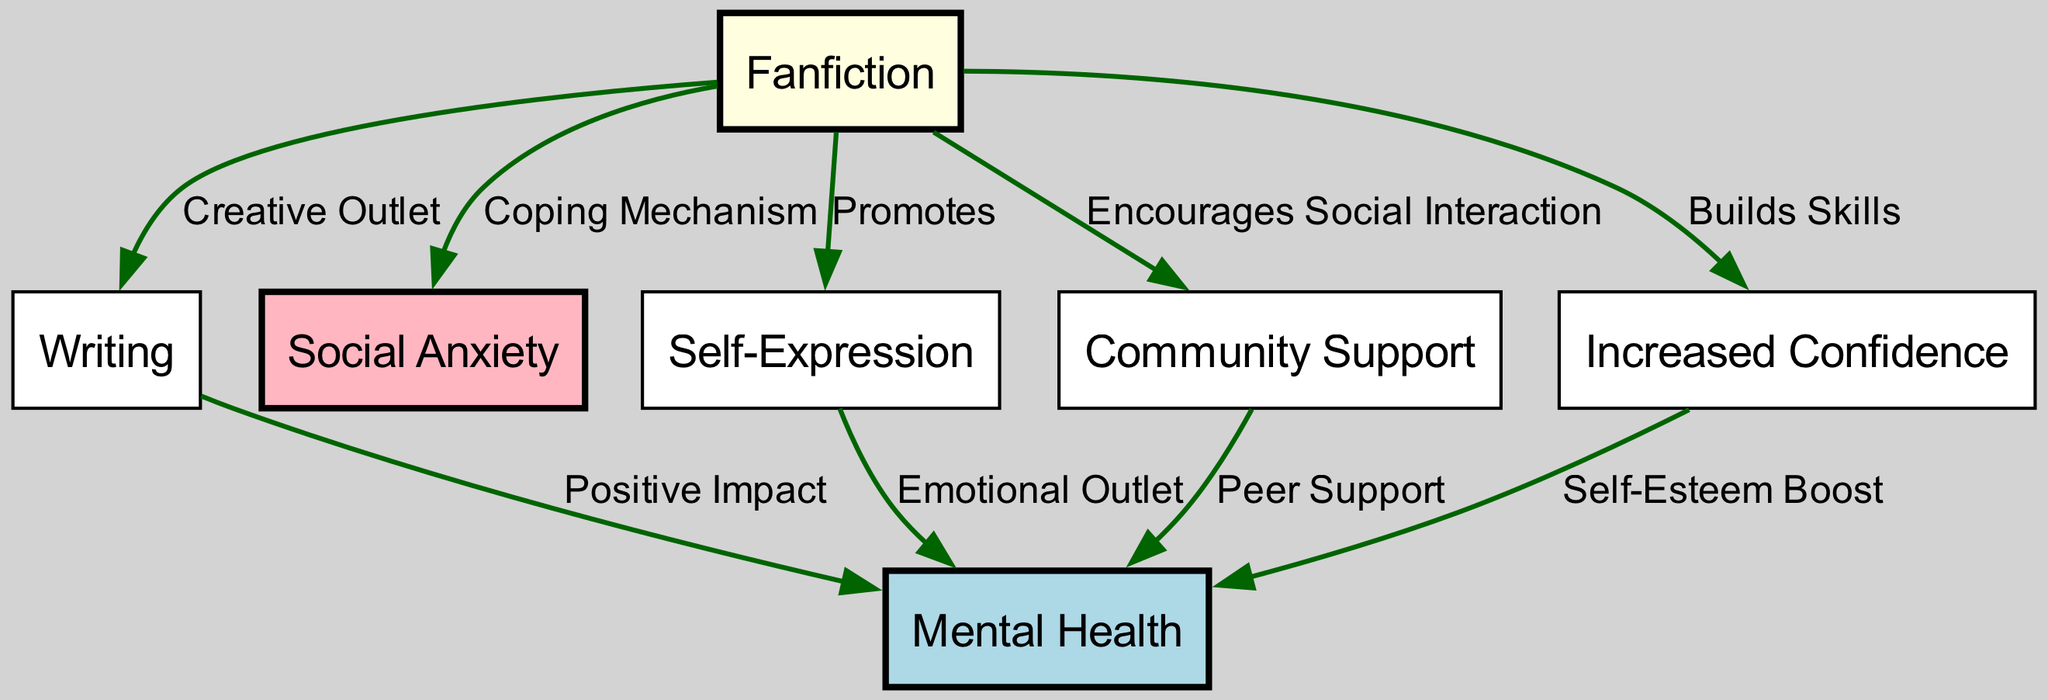What is the primary focus of the diagram? The primary focus is the influence of writing on mental health, particularly the role of fanfiction as a coping mechanism. This can be inferred from the title of the diagram and the central connections made between writing, mental health, and fanfiction.
Answer: Influence of writing on mental health How many nodes are in the diagram? To determine the number of nodes, we can count all the unique elements represented in the diagram. There are 7 distinct nodes listed in the data, which include writing, mental health, fanfiction, social anxiety, self-expression, community support, and increased confidence.
Answer: 7 What type of impact does writing have on mental health? The edge connecting writing to mental health specifies a "Positive Impact." This is a direct relationship indicated visually in the diagram, highlighting the beneficial effects of writing on mental well-being.
Answer: Positive Impact Which node represents social anxiety? The node labeled "Social Anxiety" is specifically designated in the diagram as it is included in the nodes provided. The unique identifiers allow us to easily locate and identify social anxiety within the structure.
Answer: Social Anxiety How does fanfiction relate to social anxiety? The diagram shows that fanfiction serves as a "Coping Mechanism" for social anxiety. This implies that engaging in fanfiction writing can help mitigate feelings of social anxiety, as indicated by the directed edge between these two nodes.
Answer: Coping Mechanism What effect does community support have on mental health? The diagram indicates that "Community Support" has a positive relationship with mental health, as shown by the edge connecting these two nodes labeled as "Peer Support." This suggests that support from others contributes to better mental health outcomes.
Answer: Peer Support What does fanfiction promote in the context of mental health? Fanfiction promotes "Self-Expression" according to the directed edge between these two nodes in the diagram. This indicates that writing fanfiction allows individuals to express their emotions and thoughts, which is beneficial for mental health.
Answer: Self-Expression What is one way fanfiction builds confidence? The diagram notes that fanfiction builds skills, which can enhance "Increased Confidence." This implies that as individuals engage in fanfiction writing, they may develop writing skills and self-assurance in their abilities.
Answer: Builds Skills 